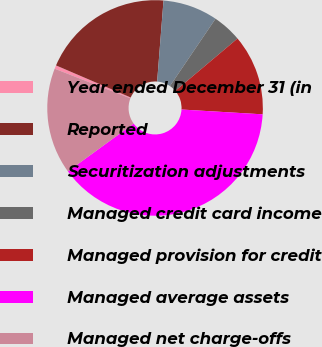Convert chart to OTSL. <chart><loc_0><loc_0><loc_500><loc_500><pie_chart><fcel>Year ended December 31 (in<fcel>Reported<fcel>Securitization adjustments<fcel>Managed credit card income<fcel>Managed provision for credit<fcel>Managed average assets<fcel>Managed net charge-offs<nl><fcel>0.53%<fcel>19.79%<fcel>8.23%<fcel>4.38%<fcel>12.08%<fcel>39.05%<fcel>15.94%<nl></chart> 